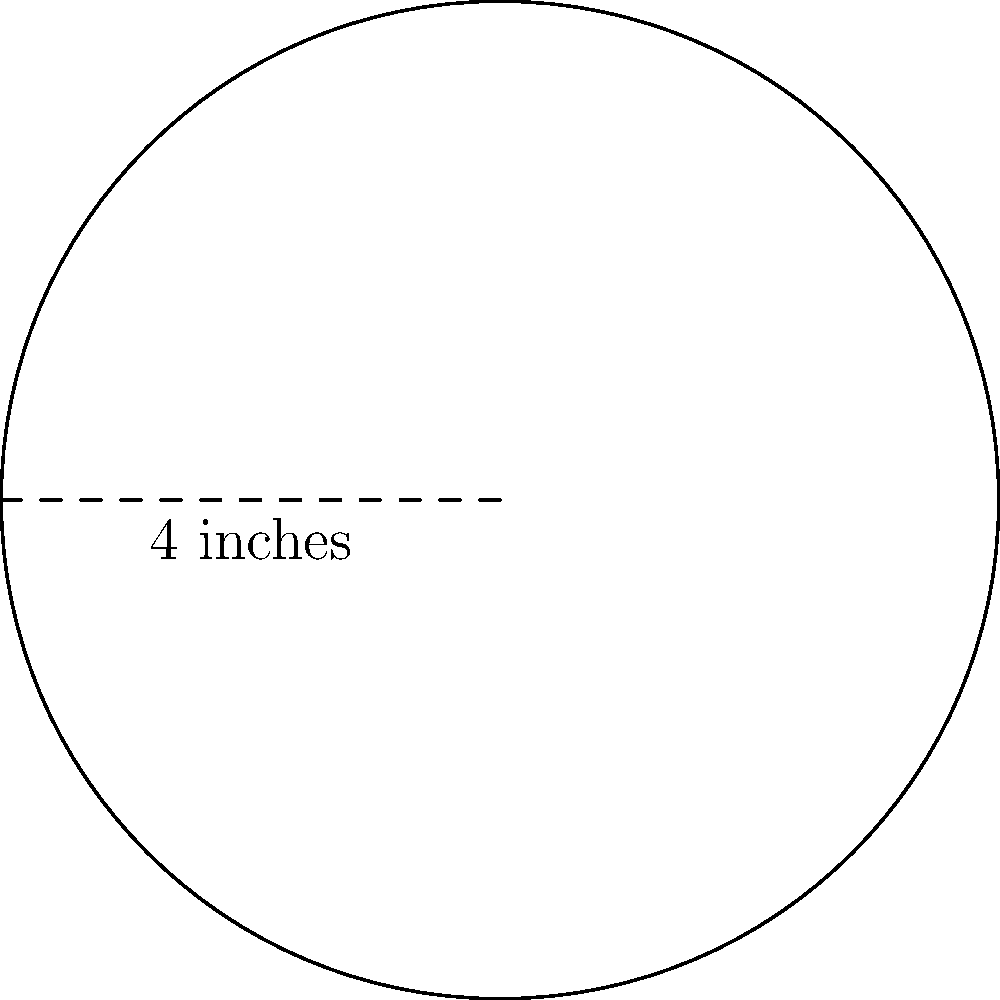You're creating a circular appliqué for your quilt. If the diameter of the circle is 4 inches, what is the circumference of the appliqué? Round your answer to the nearest tenth of an inch. Let's approach this step-by-step:

1) The formula for the circumference of a circle is:
   $$C = 2\pi r$$
   where $C$ is the circumference, $\pi$ is pi, and $r$ is the radius.

2) We're given the diameter, which is 4 inches. The radius is half of the diameter:
   $$r = 4 \div 2 = 2\text{ inches}$$

3) Now, let's substitute this into our formula:
   $$C = 2\pi (2)$$

4) Simplify:
   $$C = 4\pi$$

5) Calculate (using 3.14159 for $\pi$):
   $$C = 4 * 3.14159 = 12.56636\text{ inches}$$

6) Rounding to the nearest tenth:
   $$C \approx 12.6\text{ inches}$$
Answer: 12.6 inches 